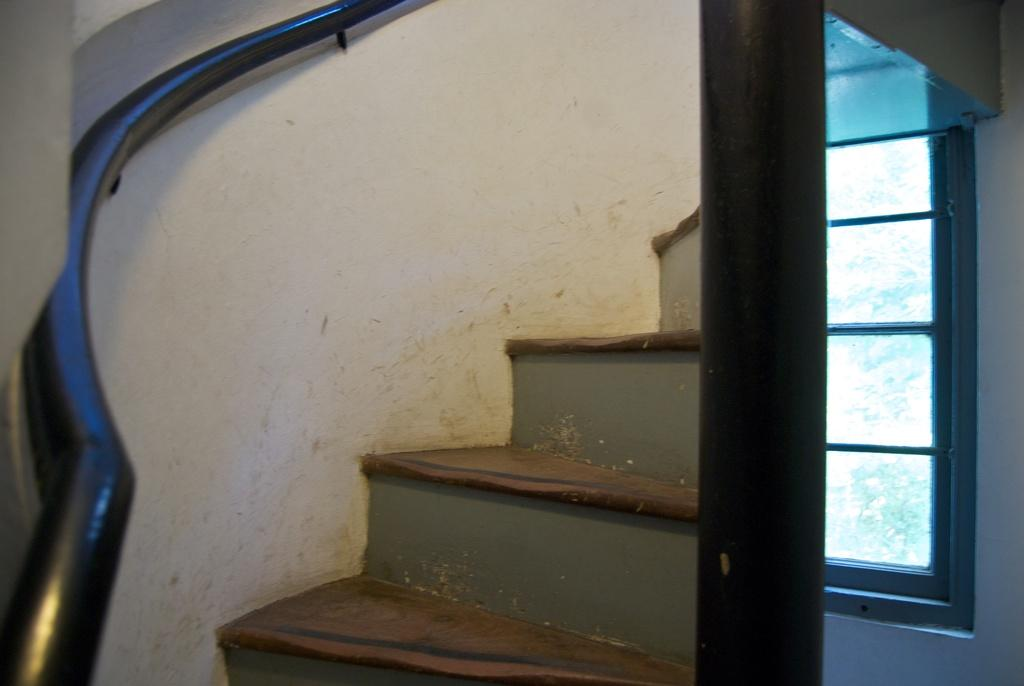What can be seen through the window in the image? Trees are visible through the window in the image. What architectural feature is present in the image? There are stairs in the image. What color is the wall in the image? The wall in the image is white-colored. What type of material is the black object in the image made of? The black object in the image is made of black-colored metal. What direction is the rake leaning in the image? There is no rake present in the image. Is the smoke coming from the wall in the image? There is no smoke present in the image. 